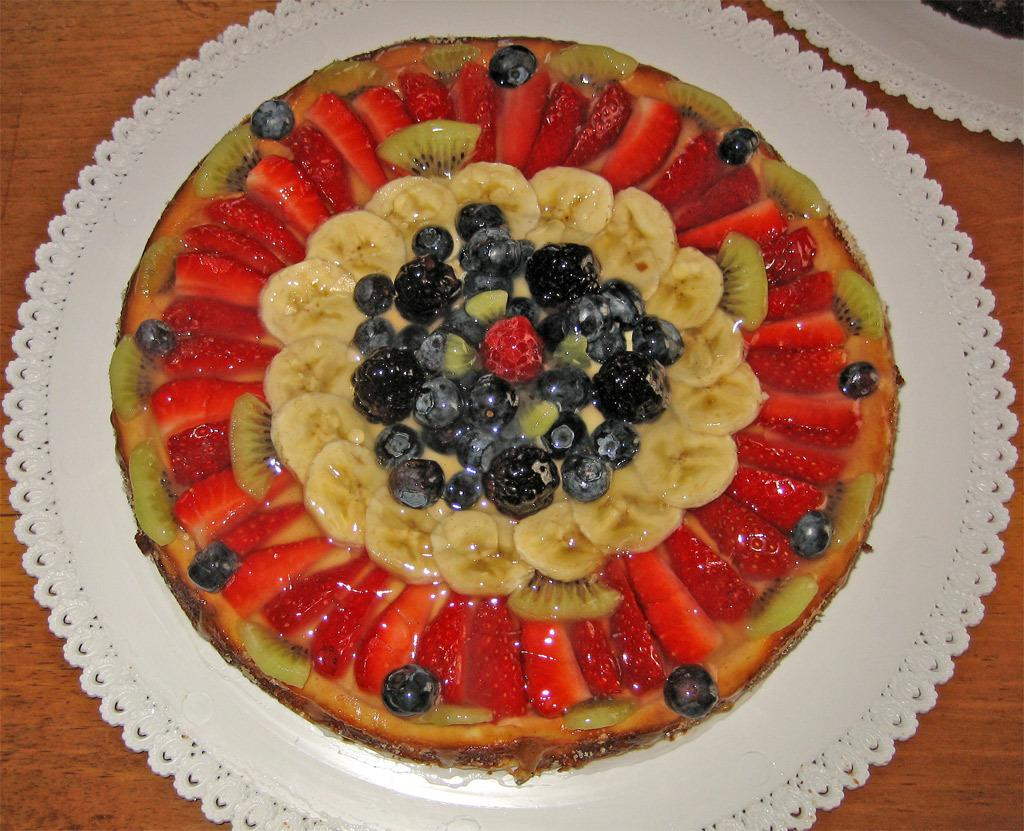What type of food is featured in the image? There is a fruit salad in the image. What specific fruits are included in the fruit salad? The fruit salad contains banana slices, grapes, strawberries, and kiwi. How is the fruit salad arranged on the plate? The fruit salad is arranged in a circular manner. Where is the plate with the fruit salad located? The plate is on a table. Can you see a plough being used near the seashore in the image? No, there is no plough or seashore present in the image. The image features a fruit salad arranged in a circular manner on a plate, which is located on a table. 